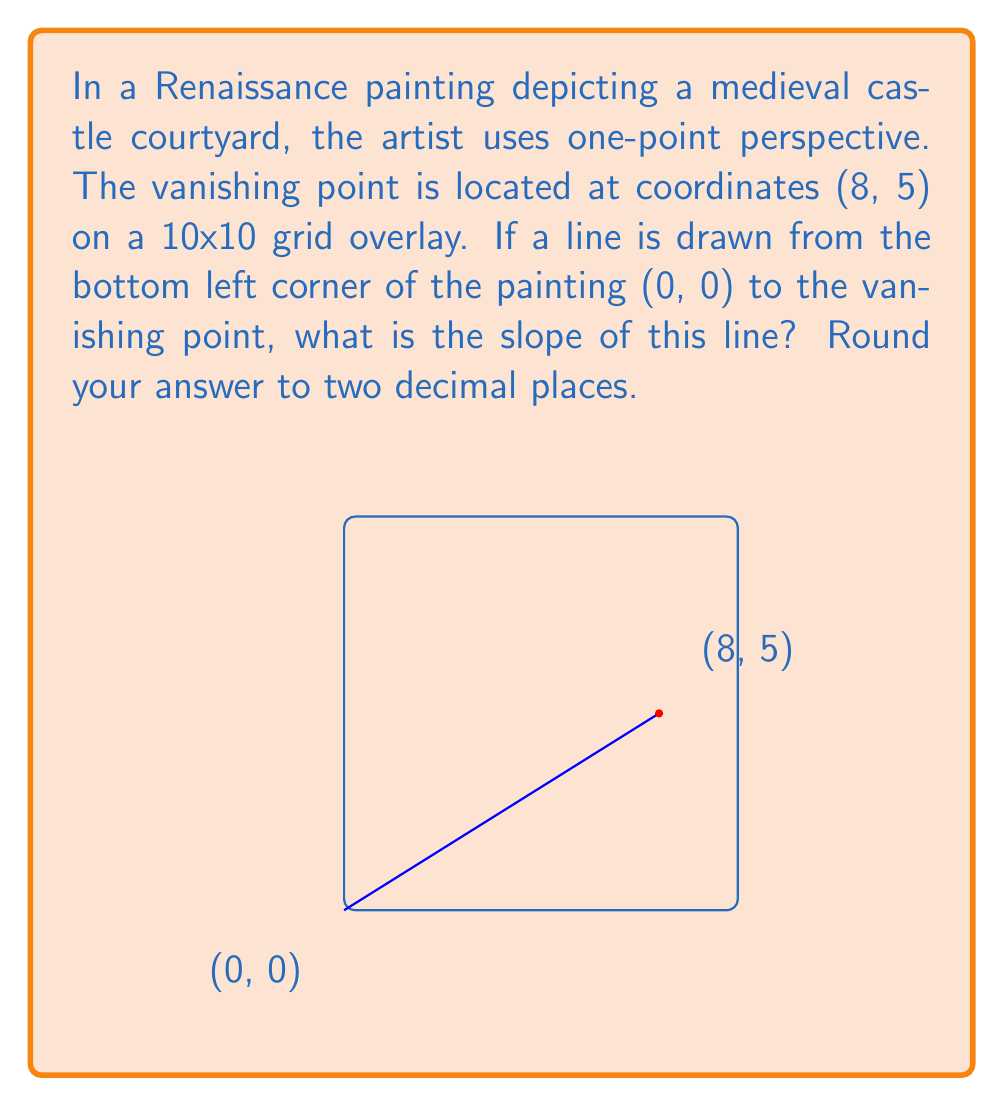Can you answer this question? To find the slope of the line, we can use the slope formula:

$$ m = \frac{y_2 - y_1}{x_2 - x_1} $$

Where $(x_1, y_1)$ is the starting point (bottom left corner) and $(x_2, y_2)$ is the endpoint (vanishing point).

Given:
- Starting point: (0, 0)
- Endpoint (vanishing point): (8, 5)

Let's plug these values into the slope formula:

$$ m = \frac{5 - 0}{8 - 0} = \frac{5}{8} = 0.625 $$

Rounding to two decimal places:

$$ m \approx 0.63 $$

This slope represents the rate at which the line rises as it moves from the bottom left corner to the vanishing point, which is crucial in creating the illusion of depth and perspective in Renaissance paintings.
Answer: 0.63 